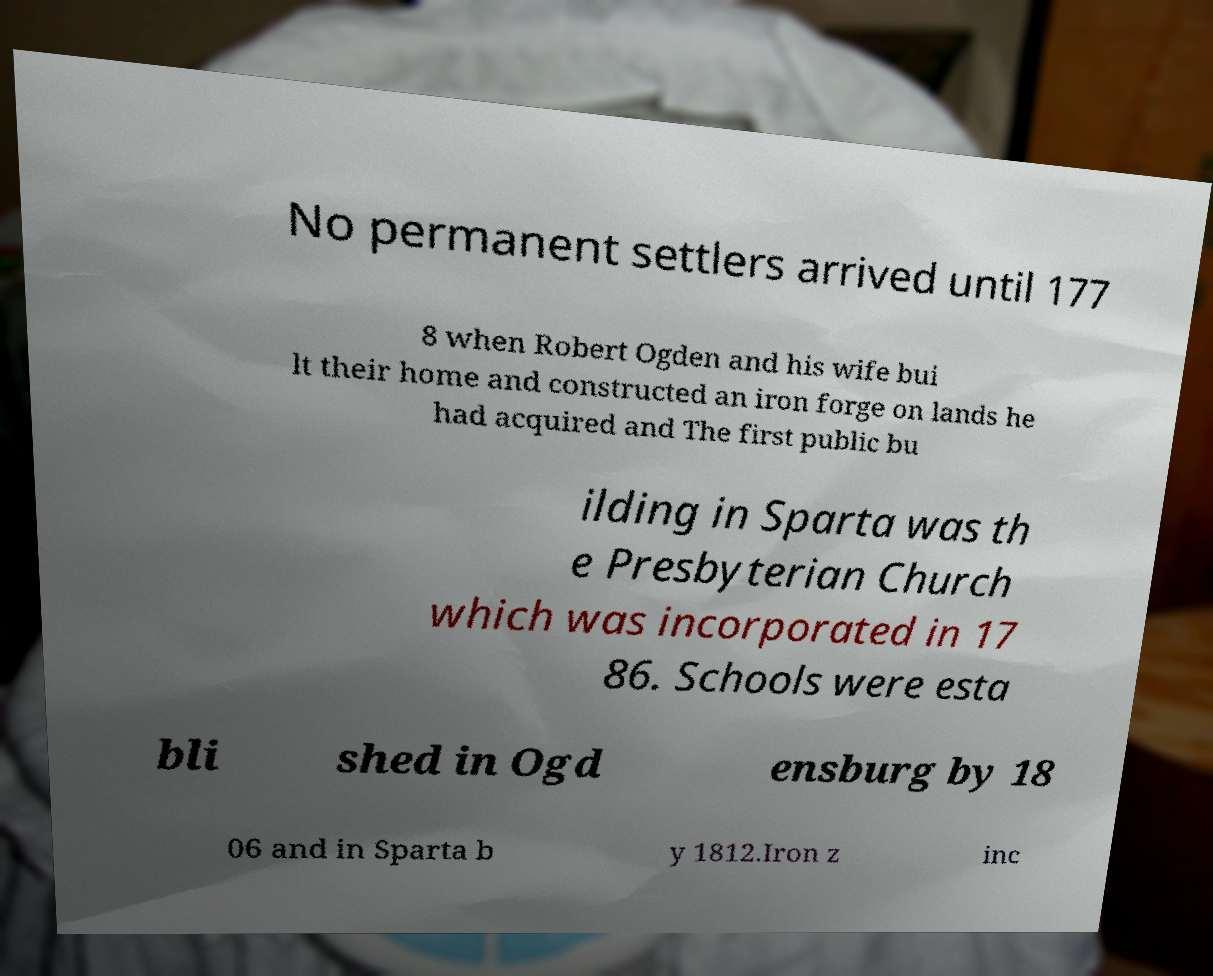Please read and relay the text visible in this image. What does it say? No permanent settlers arrived until 177 8 when Robert Ogden and his wife bui lt their home and constructed an iron forge on lands he had acquired and The first public bu ilding in Sparta was th e Presbyterian Church which was incorporated in 17 86. Schools were esta bli shed in Ogd ensburg by 18 06 and in Sparta b y 1812.Iron z inc 